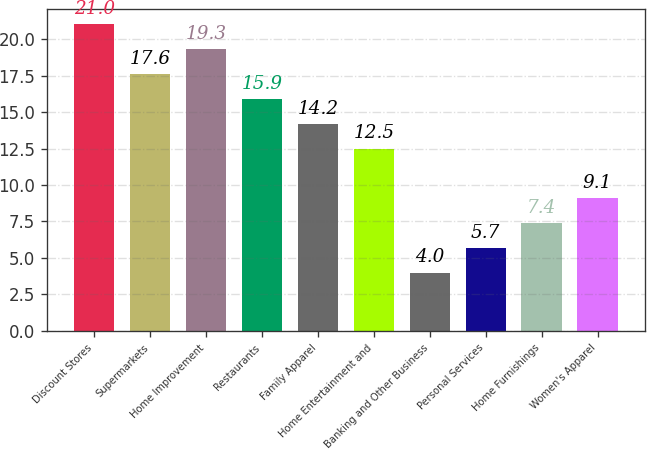Convert chart to OTSL. <chart><loc_0><loc_0><loc_500><loc_500><bar_chart><fcel>Discount Stores<fcel>Supermarkets<fcel>Home Improvement<fcel>Restaurants<fcel>Family Apparel<fcel>Home Entertainment and<fcel>Banking and Other Business<fcel>Personal Services<fcel>Home Furnishings<fcel>Women's Apparel<nl><fcel>21<fcel>17.6<fcel>19.3<fcel>15.9<fcel>14.2<fcel>12.5<fcel>4<fcel>5.7<fcel>7.4<fcel>9.1<nl></chart> 